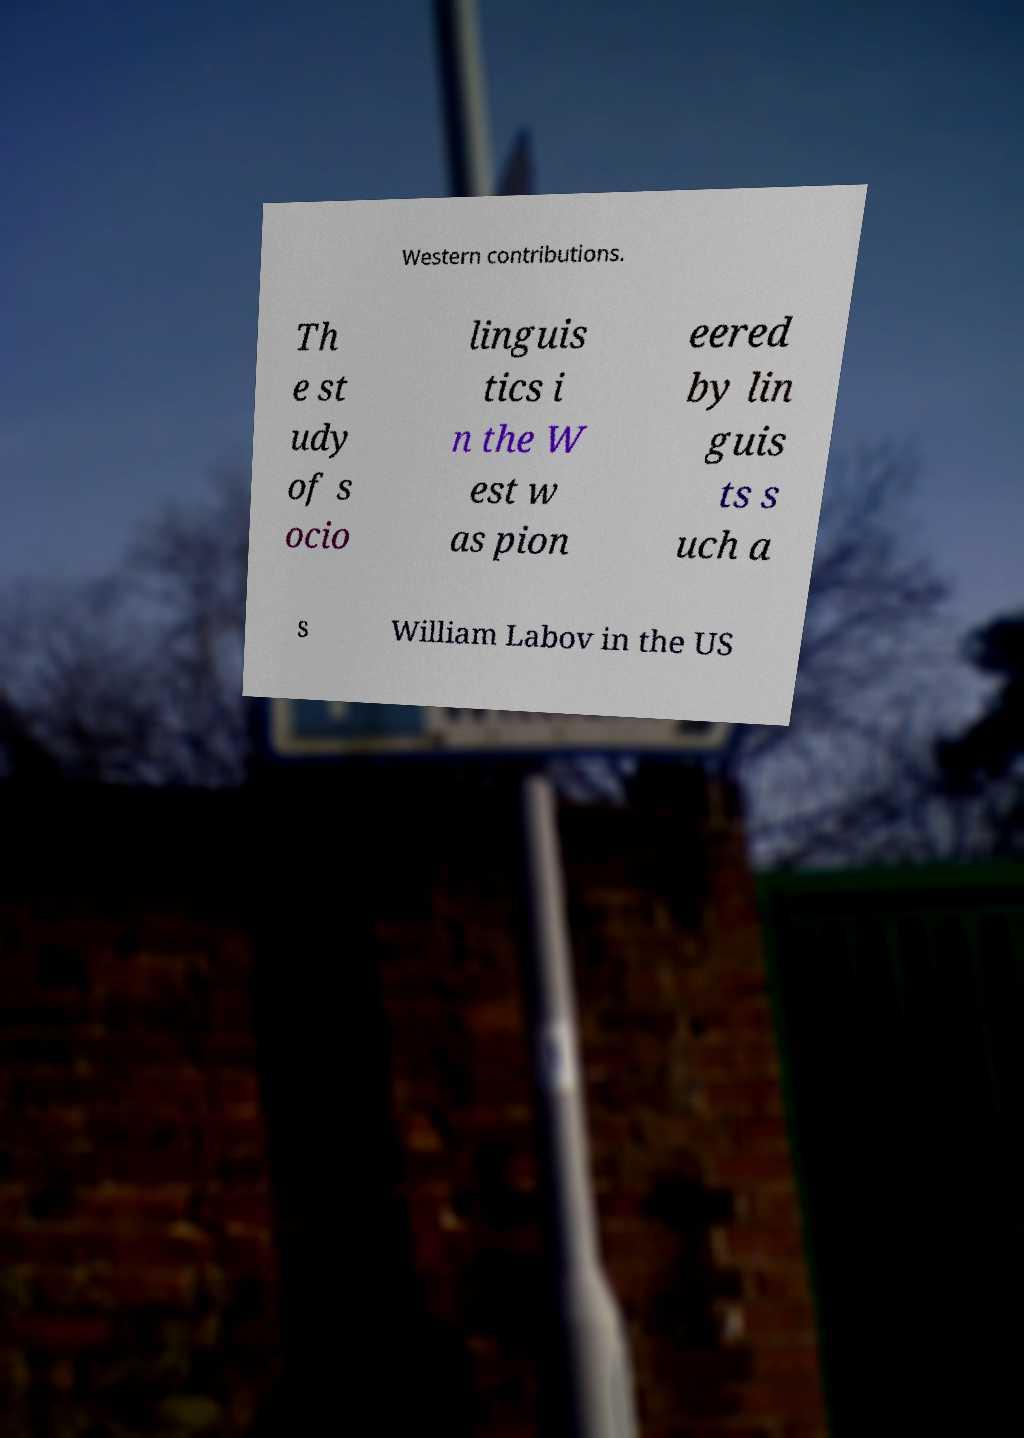Can you accurately transcribe the text from the provided image for me? Western contributions. Th e st udy of s ocio linguis tics i n the W est w as pion eered by lin guis ts s uch a s William Labov in the US 